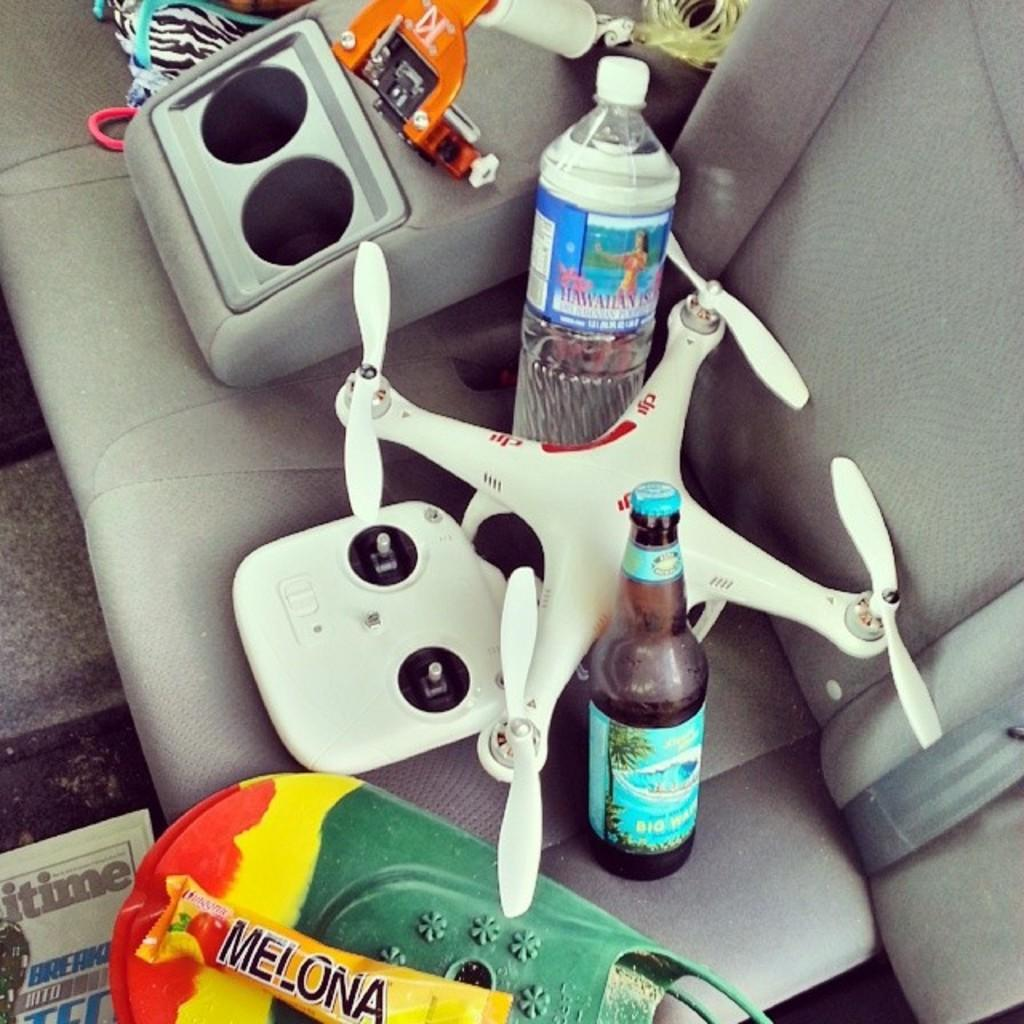<image>
Provide a brief description of the given image. a drone next to a bottle of beer and water called hawaiian island 